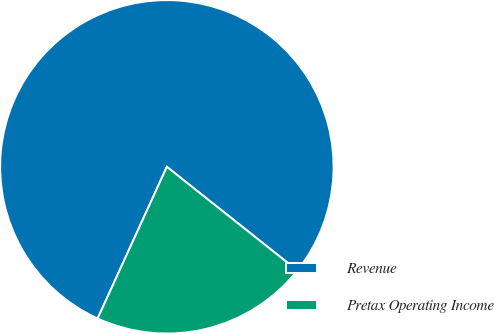<chart> <loc_0><loc_0><loc_500><loc_500><pie_chart><fcel>Revenue<fcel>Pretax Operating Income<nl><fcel>78.87%<fcel>21.13%<nl></chart> 